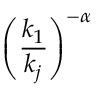Convert formula to latex. <formula><loc_0><loc_0><loc_500><loc_500>\left ( \frac { k _ { 1 } } { k _ { j } } \right ) ^ { - \alpha }</formula> 